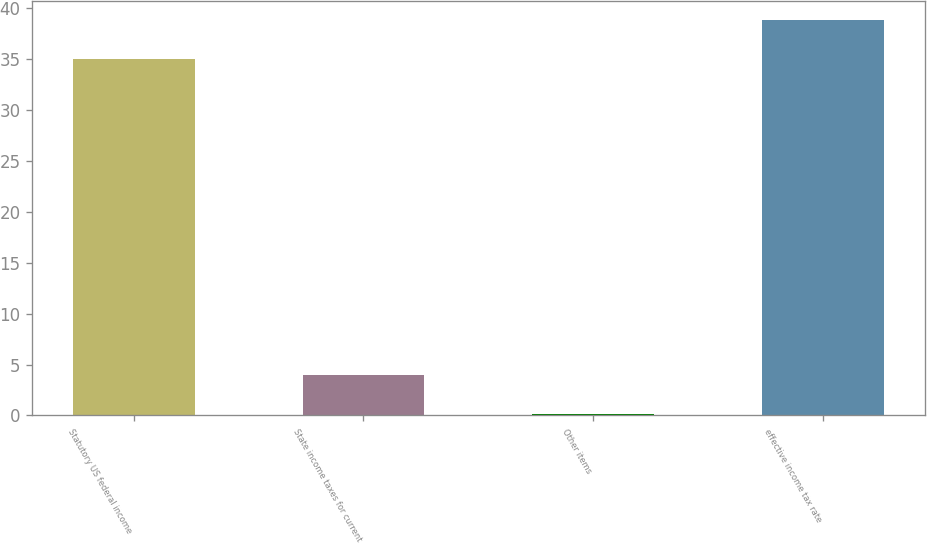Convert chart to OTSL. <chart><loc_0><loc_0><loc_500><loc_500><bar_chart><fcel>Statutory US federal income<fcel>State income taxes for current<fcel>Other items<fcel>effective income tax rate<nl><fcel>35<fcel>3.93<fcel>0.1<fcel>38.83<nl></chart> 